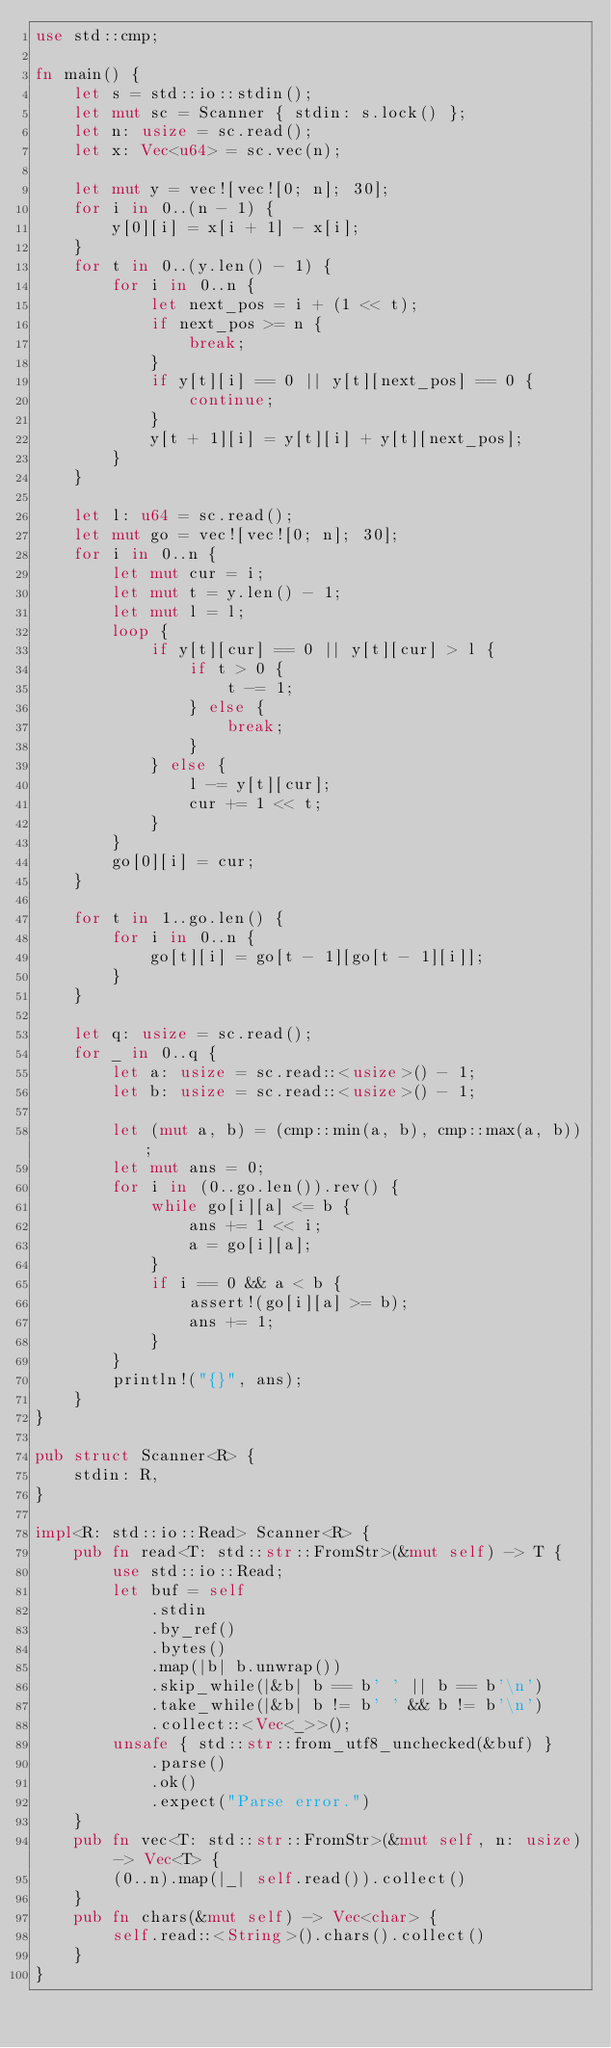Convert code to text. <code><loc_0><loc_0><loc_500><loc_500><_Rust_>use std::cmp;

fn main() {
    let s = std::io::stdin();
    let mut sc = Scanner { stdin: s.lock() };
    let n: usize = sc.read();
    let x: Vec<u64> = sc.vec(n);

    let mut y = vec![vec![0; n]; 30];
    for i in 0..(n - 1) {
        y[0][i] = x[i + 1] - x[i];
    }
    for t in 0..(y.len() - 1) {
        for i in 0..n {
            let next_pos = i + (1 << t);
            if next_pos >= n {
                break;
            }
            if y[t][i] == 0 || y[t][next_pos] == 0 {
                continue;
            }
            y[t + 1][i] = y[t][i] + y[t][next_pos];
        }
    }

    let l: u64 = sc.read();
    let mut go = vec![vec![0; n]; 30];
    for i in 0..n {
        let mut cur = i;
        let mut t = y.len() - 1;
        let mut l = l;
        loop {
            if y[t][cur] == 0 || y[t][cur] > l {
                if t > 0 {
                    t -= 1;
                } else {
                    break;
                }
            } else {
                l -= y[t][cur];
                cur += 1 << t;
            }
        }
        go[0][i] = cur;
    }

    for t in 1..go.len() {
        for i in 0..n {
            go[t][i] = go[t - 1][go[t - 1][i]];
        }
    }

    let q: usize = sc.read();
    for _ in 0..q {
        let a: usize = sc.read::<usize>() - 1;
        let b: usize = sc.read::<usize>() - 1;

        let (mut a, b) = (cmp::min(a, b), cmp::max(a, b));
        let mut ans = 0;
        for i in (0..go.len()).rev() {
            while go[i][a] <= b {
                ans += 1 << i;
                a = go[i][a];
            }
            if i == 0 && a < b {
                assert!(go[i][a] >= b);
                ans += 1;
            }
        }
        println!("{}", ans);
    }
}

pub struct Scanner<R> {
    stdin: R,
}

impl<R: std::io::Read> Scanner<R> {
    pub fn read<T: std::str::FromStr>(&mut self) -> T {
        use std::io::Read;
        let buf = self
            .stdin
            .by_ref()
            .bytes()
            .map(|b| b.unwrap())
            .skip_while(|&b| b == b' ' || b == b'\n')
            .take_while(|&b| b != b' ' && b != b'\n')
            .collect::<Vec<_>>();
        unsafe { std::str::from_utf8_unchecked(&buf) }
            .parse()
            .ok()
            .expect("Parse error.")
    }
    pub fn vec<T: std::str::FromStr>(&mut self, n: usize) -> Vec<T> {
        (0..n).map(|_| self.read()).collect()
    }
    pub fn chars(&mut self) -> Vec<char> {
        self.read::<String>().chars().collect()
    }
}
</code> 